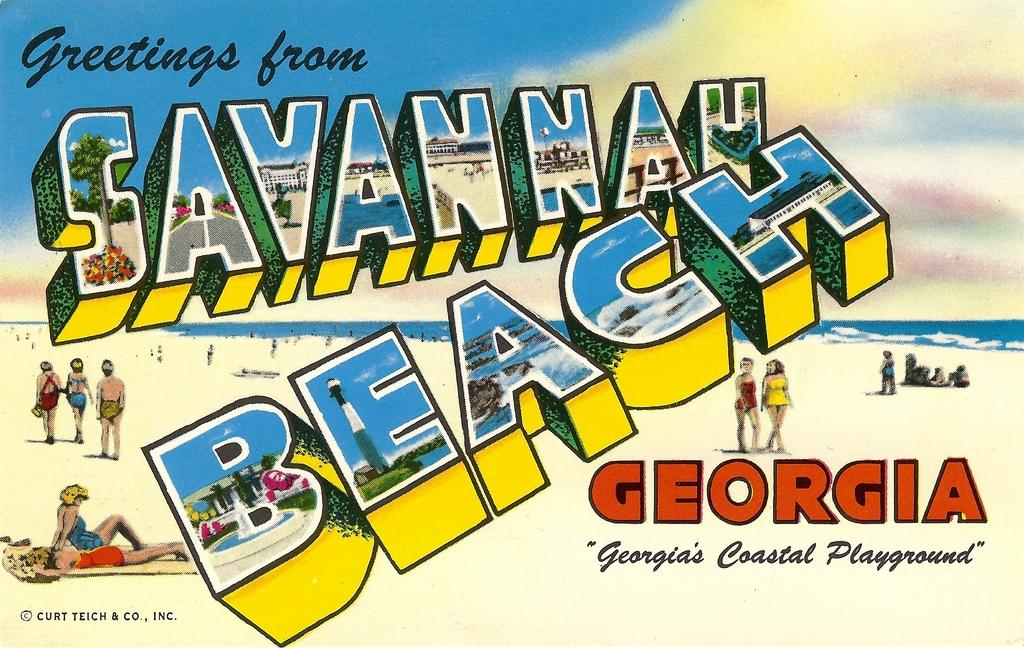<image>
Relay a brief, clear account of the picture shown. A postcard from Savannah Beach is giving greetings to visitors. 